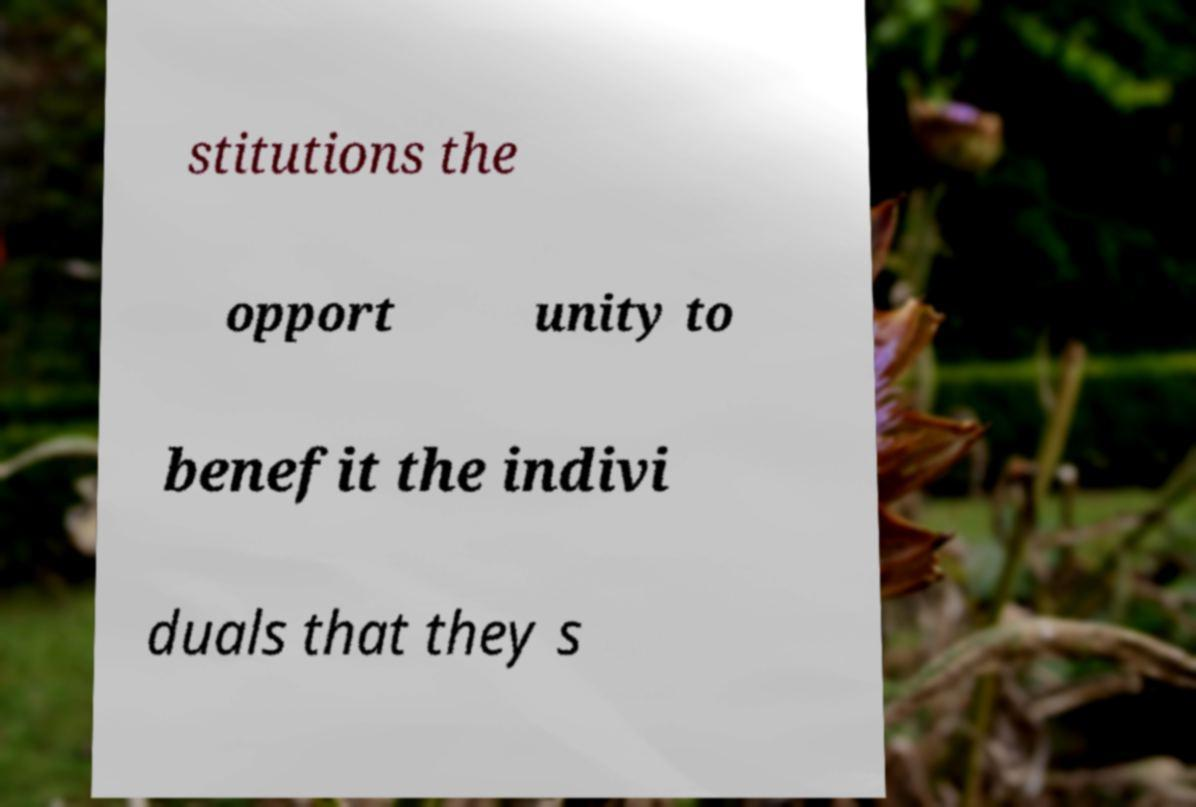Can you accurately transcribe the text from the provided image for me? stitutions the opport unity to benefit the indivi duals that they s 